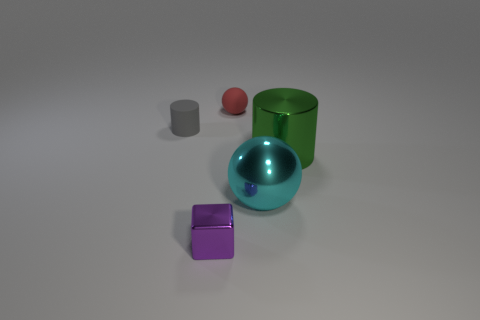What number of objects are the same size as the purple metallic block?
Provide a short and direct response. 2. Does the tiny object that is on the right side of the purple object have the same shape as the cyan metal object that is right of the cube?
Make the answer very short. Yes. What color is the matte thing that is on the left side of the rubber thing behind the gray rubber cylinder?
Give a very brief answer. Gray. There is a metal object that is the same shape as the tiny red matte object; what is its color?
Your answer should be compact. Cyan. The green metallic object that is the same shape as the gray rubber object is what size?
Your answer should be very brief. Large. There is a cylinder that is in front of the gray thing; what is its material?
Provide a succinct answer. Metal. Are there fewer big cyan metallic objects behind the cyan thing than gray objects?
Ensure brevity in your answer.  Yes. There is a large metallic object in front of the large thing behind the big cyan shiny thing; what shape is it?
Offer a terse response. Sphere. The tiny shiny thing is what color?
Make the answer very short. Purple. How many other objects are there of the same size as the green metal object?
Your answer should be very brief. 1. 